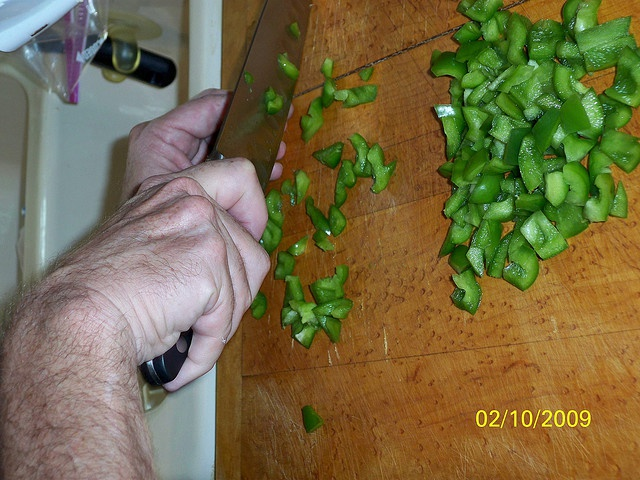Describe the objects in this image and their specific colors. I can see people in lightblue, darkgray, gray, and lightgray tones and knife in lightblue, black, and darkgreen tones in this image. 